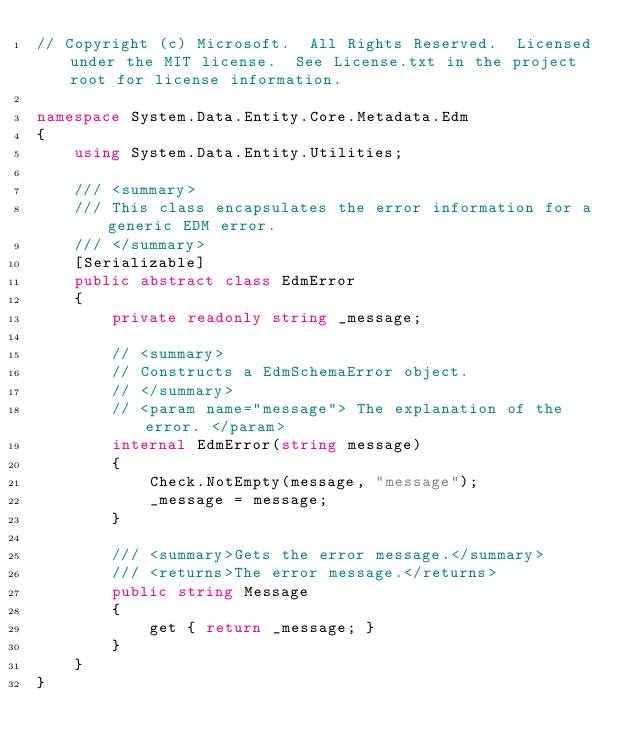<code> <loc_0><loc_0><loc_500><loc_500><_C#_>// Copyright (c) Microsoft.  All Rights Reserved.  Licensed under the MIT license.  See License.txt in the project root for license information.

namespace System.Data.Entity.Core.Metadata.Edm
{
    using System.Data.Entity.Utilities;

    /// <summary>
    /// This class encapsulates the error information for a generic EDM error.
    /// </summary>
    [Serializable]
    public abstract class EdmError
    {
        private readonly string _message;

        // <summary>
        // Constructs a EdmSchemaError object.
        // </summary>
        // <param name="message"> The explanation of the error. </param>
        internal EdmError(string message)
        {
            Check.NotEmpty(message, "message");
            _message = message;
        }

        /// <summary>Gets the error message.</summary>
        /// <returns>The error message.</returns>
        public string Message
        {
            get { return _message; }
        }
    }
}
</code> 